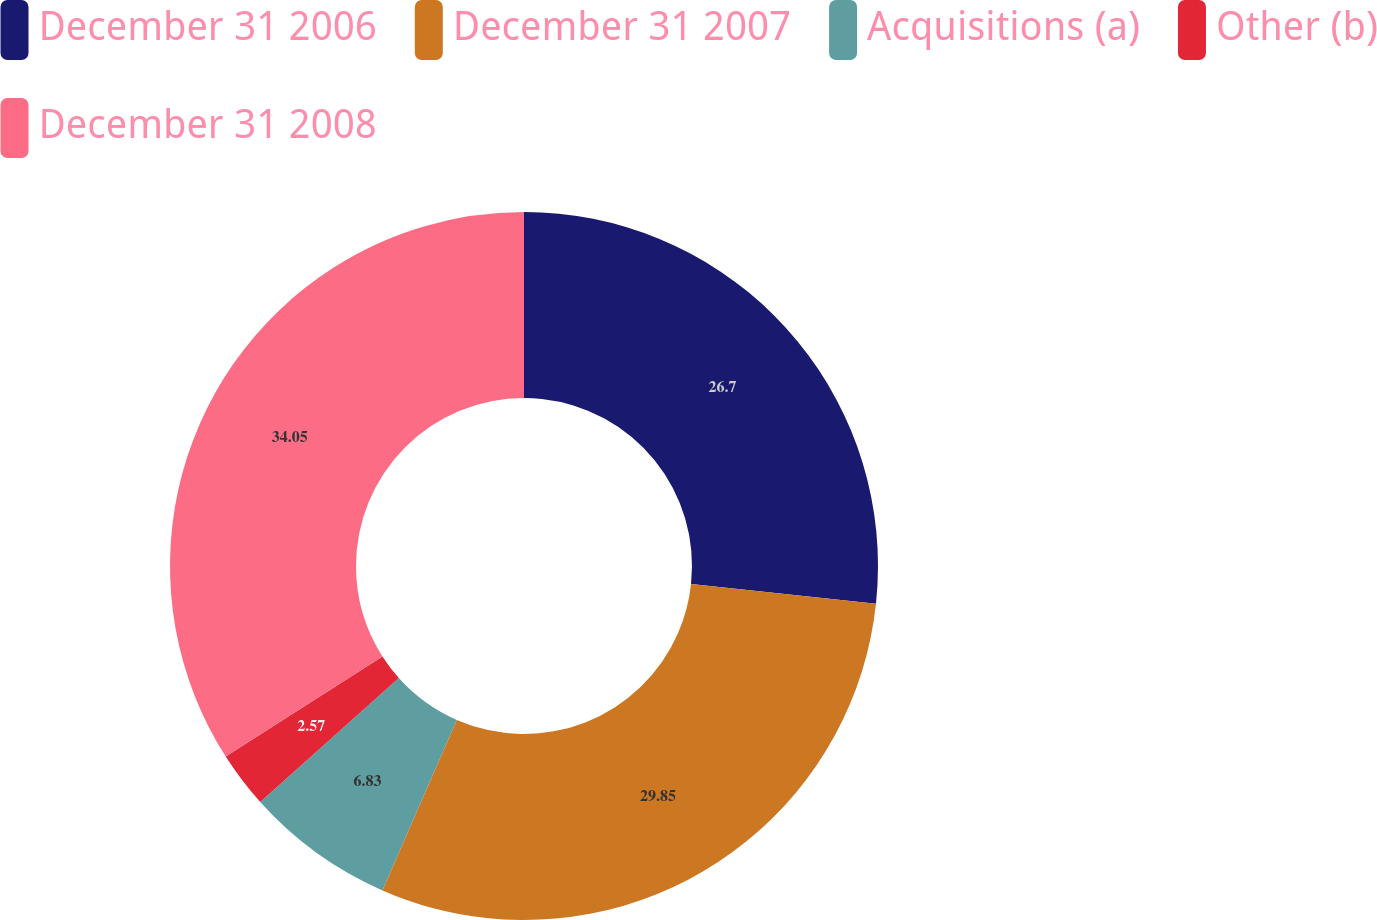<chart> <loc_0><loc_0><loc_500><loc_500><pie_chart><fcel>December 31 2006<fcel>December 31 2007<fcel>Acquisitions (a)<fcel>Other (b)<fcel>December 31 2008<nl><fcel>26.7%<fcel>29.85%<fcel>6.83%<fcel>2.57%<fcel>34.05%<nl></chart> 